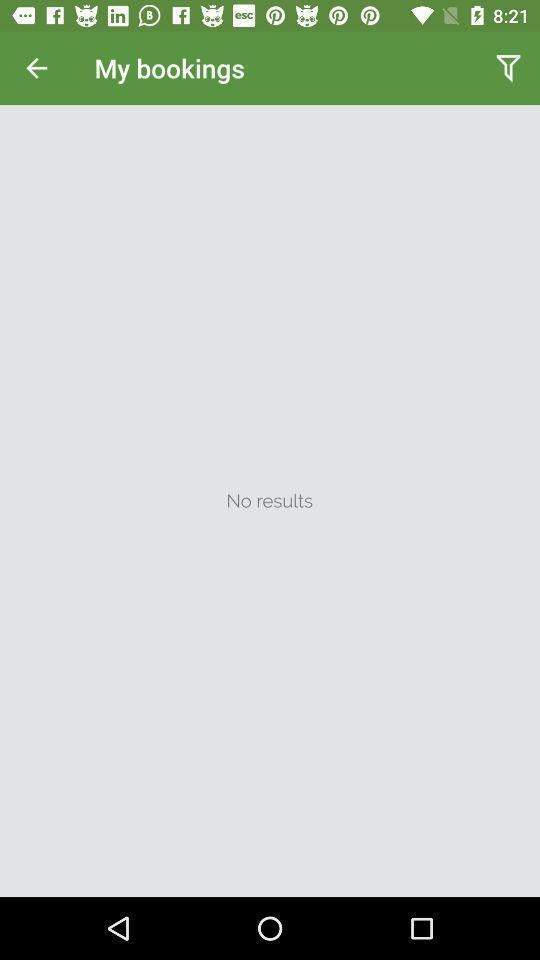Describe the key features of this screenshot. Screen display my bookings page. 